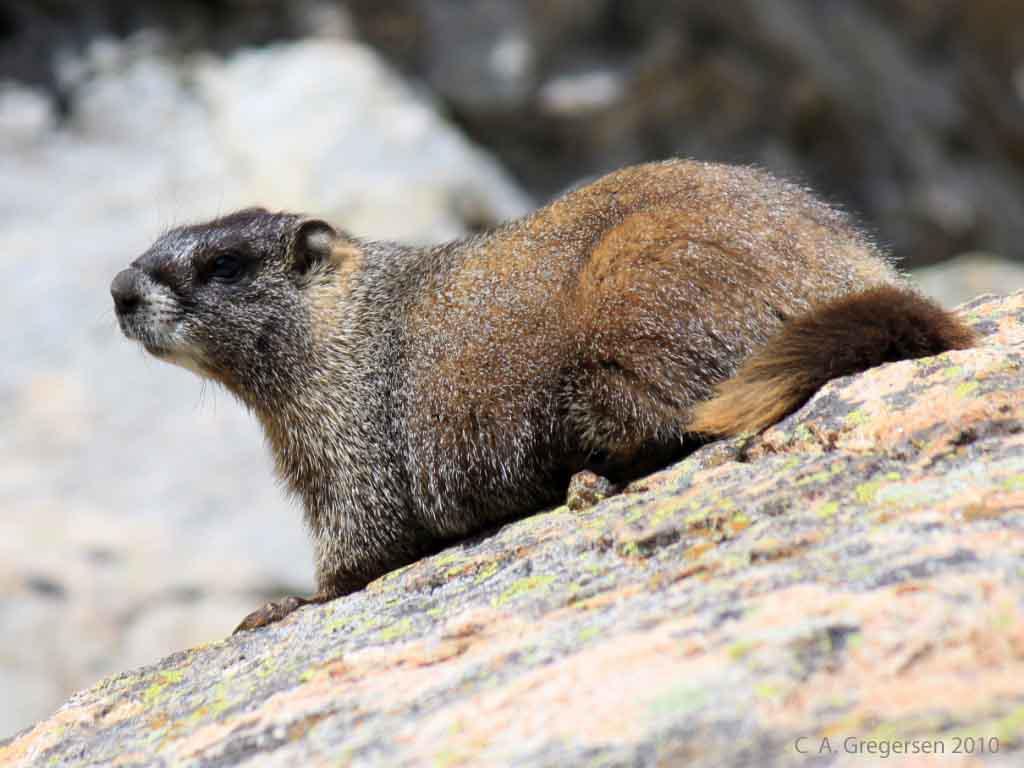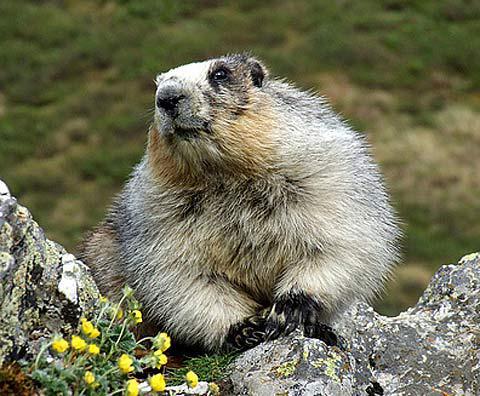The first image is the image on the left, the second image is the image on the right. Assess this claim about the two images: "There is at least one animal lying on its belly and facing left in the image on the left.". Correct or not? Answer yes or no. Yes. 